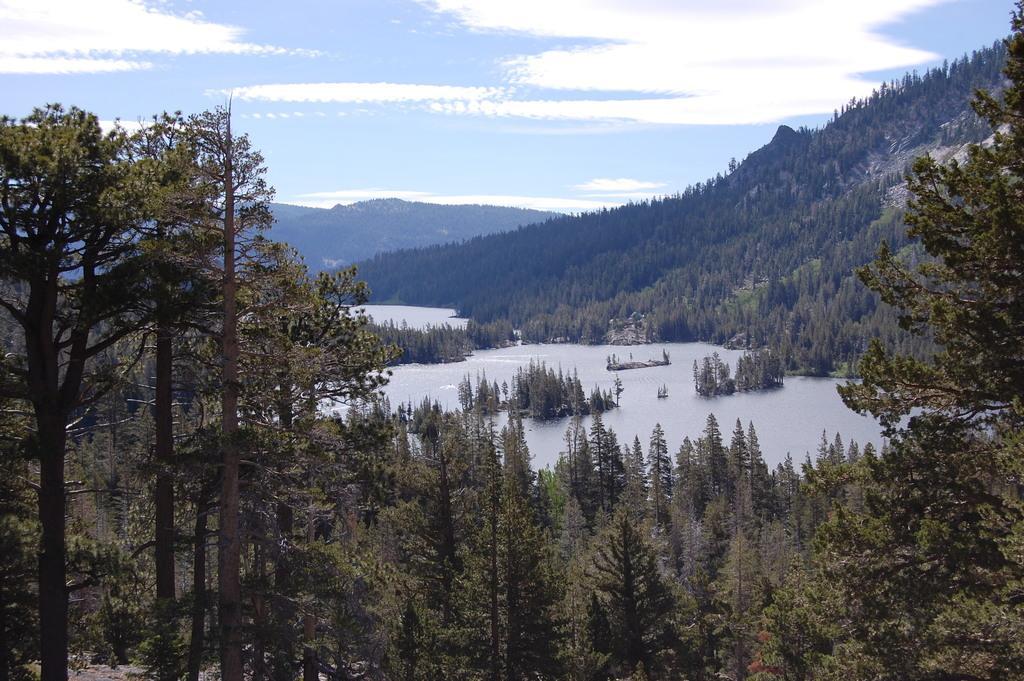How would you summarize this image in a sentence or two? In this picture we can see few trees, water, hills and clouds. 